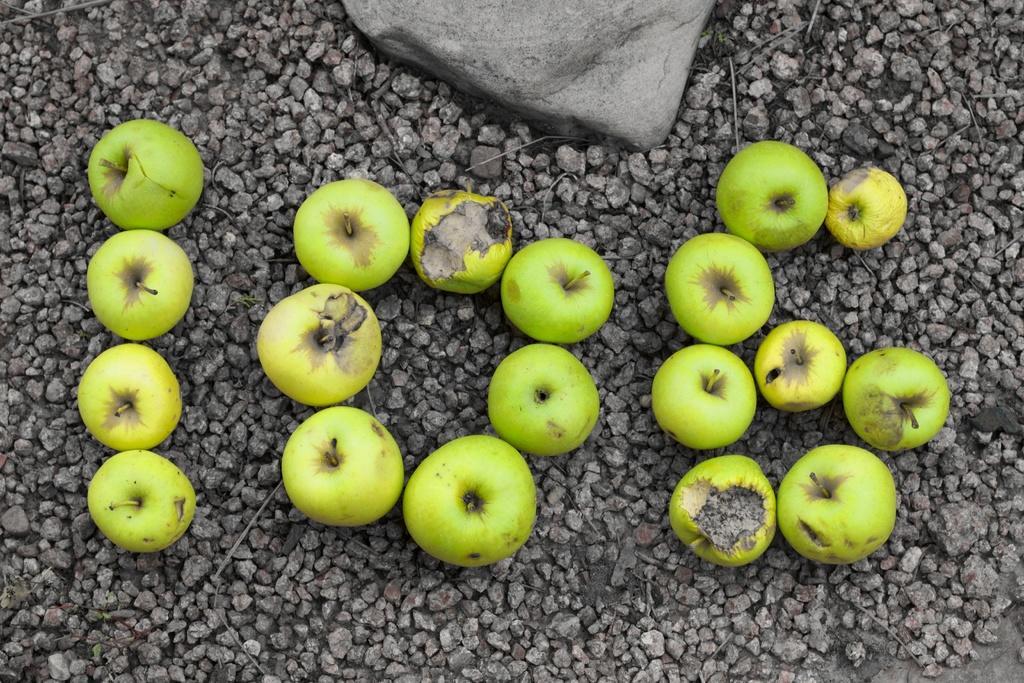How would you summarize this image in a sentence or two? In this image we can see a few green apples and stones on the ground. 